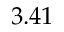<formula> <loc_0><loc_0><loc_500><loc_500>3 . 4 1</formula> 